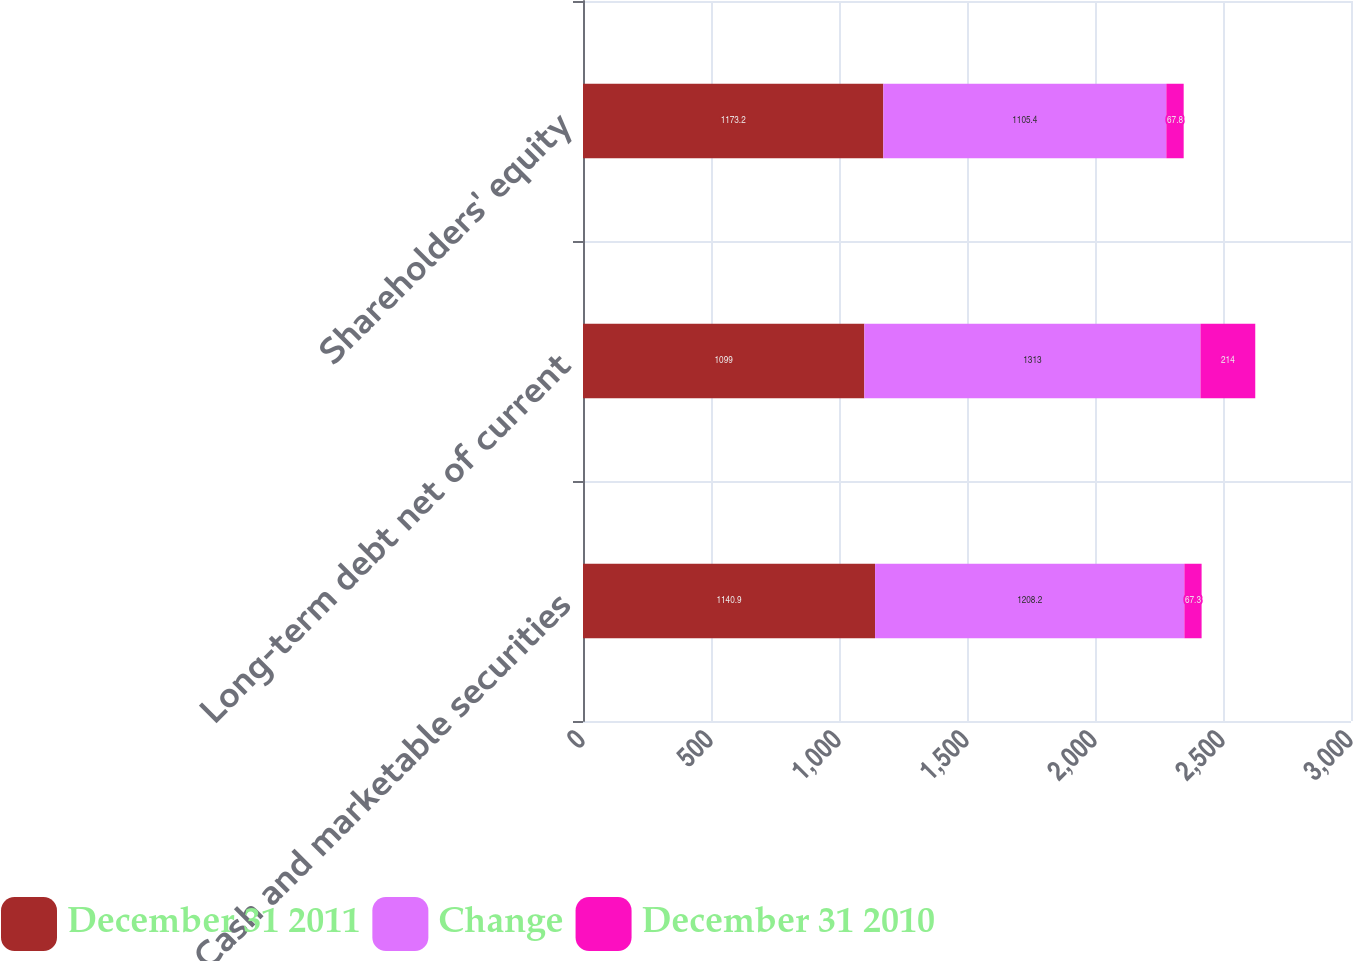Convert chart to OTSL. <chart><loc_0><loc_0><loc_500><loc_500><stacked_bar_chart><ecel><fcel>Cash and marketable securities<fcel>Long-term debt net of current<fcel>Shareholders' equity<nl><fcel>December 31 2011<fcel>1140.9<fcel>1099<fcel>1173.2<nl><fcel>Change<fcel>1208.2<fcel>1313<fcel>1105.4<nl><fcel>December 31 2010<fcel>67.3<fcel>214<fcel>67.8<nl></chart> 